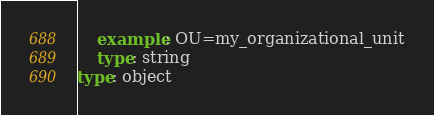<code> <loc_0><loc_0><loc_500><loc_500><_YAML_>    example: OU=my_organizational_unit
    type: string
type: object
</code> 